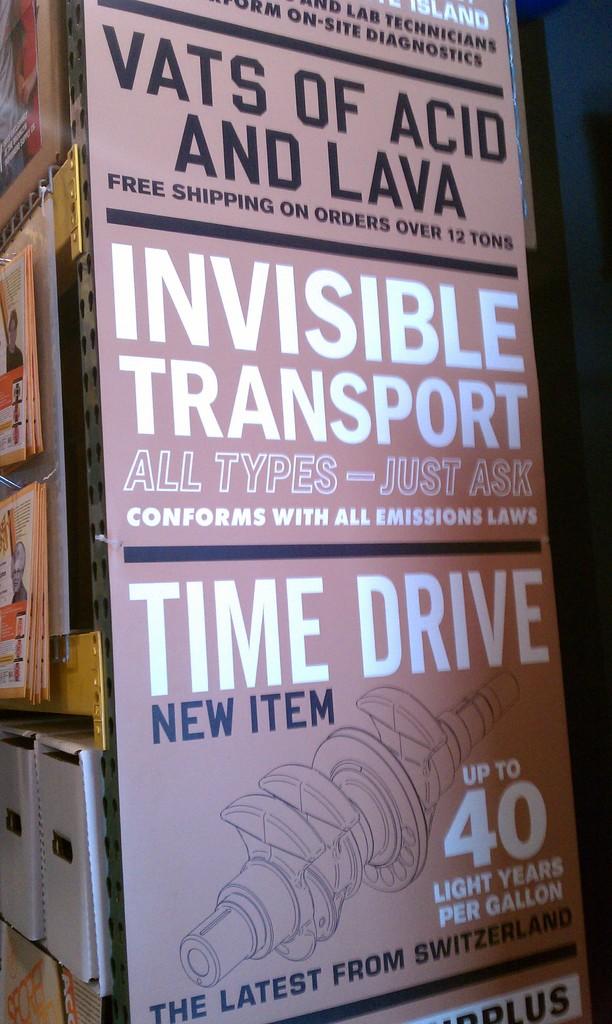What is being advertised for sale?
Make the answer very short. Time drive. What type of transport is mentioned here?
Make the answer very short. Invisible. 